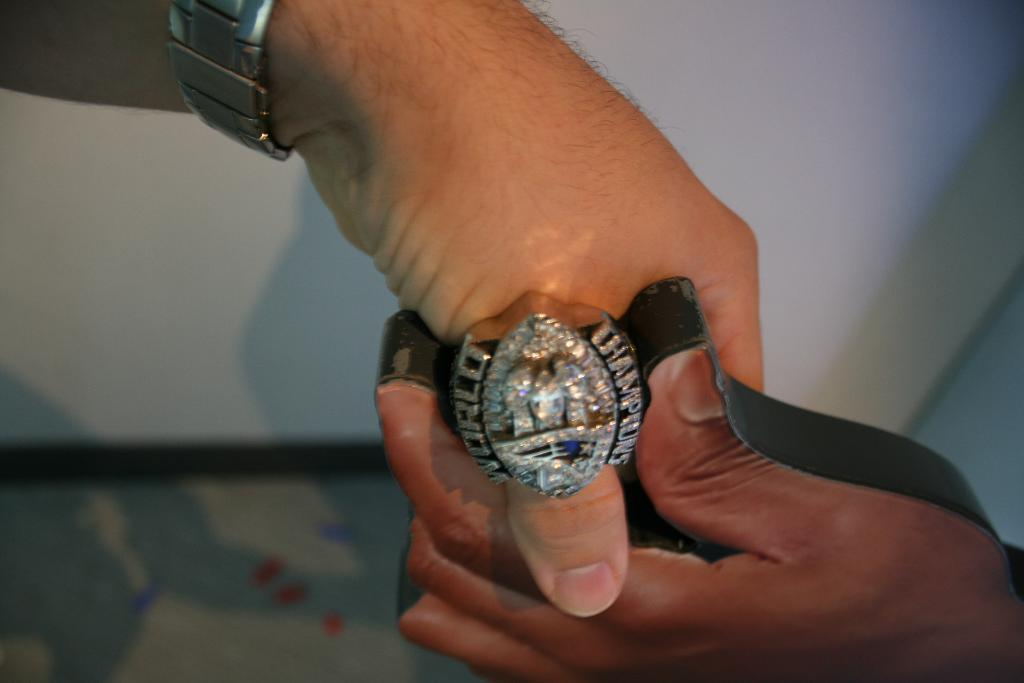Provide a one-sentence caption for the provided image. person wearing a World Champions ring with lots of diamonds in it. 